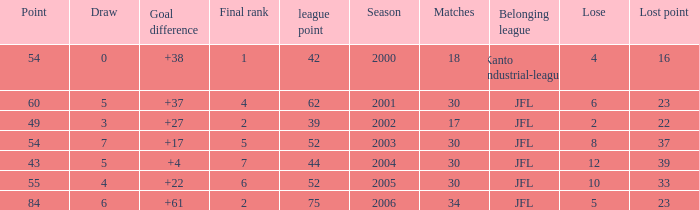I want the total number of matches for draw less than 7 and lost point of 16 with lose more than 4 0.0. 